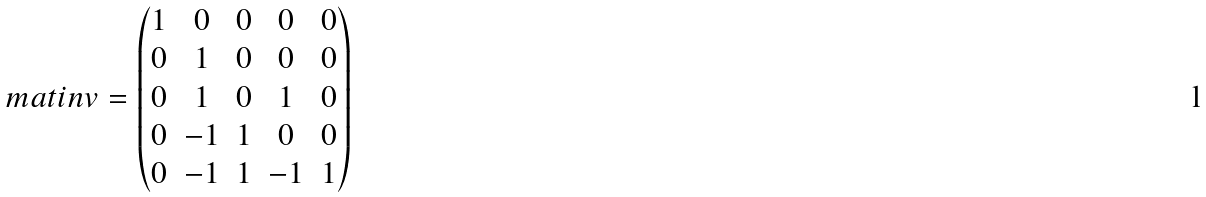<formula> <loc_0><loc_0><loc_500><loc_500>\ m a t i n v = \begin{pmatrix} 1 & 0 & 0 & 0 & 0 \\ 0 & 1 & 0 & 0 & 0 \\ 0 & 1 & 0 & 1 & 0 \\ 0 & - 1 & 1 & 0 & 0 \\ 0 & - 1 & 1 & - 1 & 1 \end{pmatrix}</formula> 